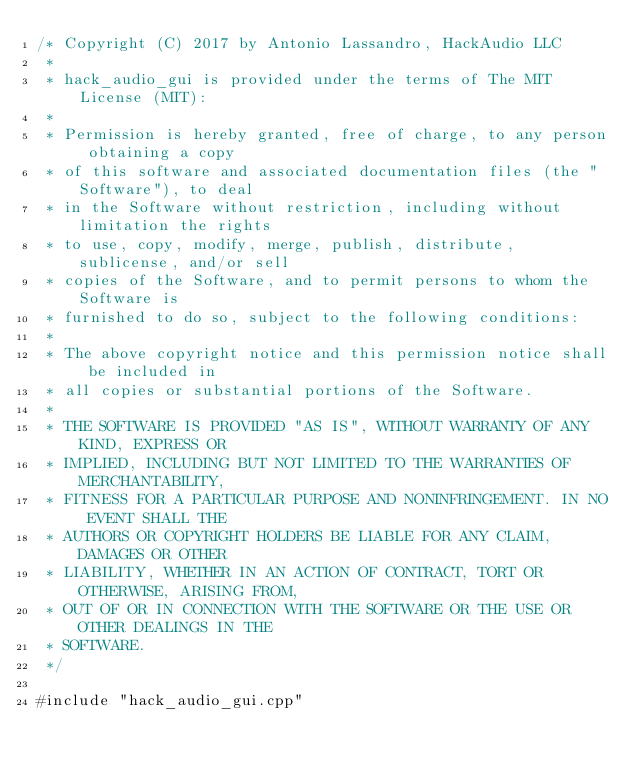<code> <loc_0><loc_0><loc_500><loc_500><_ObjectiveC_>/* Copyright (C) 2017 by Antonio Lassandro, HackAudio LLC
 *
 * hack_audio_gui is provided under the terms of The MIT License (MIT):
 *
 * Permission is hereby granted, free of charge, to any person obtaining a copy 
 * of this software and associated documentation files (the "Software"), to deal
 * in the Software without restriction, including without limitation the rights 
 * to use, copy, modify, merge, publish, distribute, sublicense, and/or sell 
 * copies of the Software, and to permit persons to whom the Software is 
 * furnished to do so, subject to the following conditions:
 *
 * The above copyright notice and this permission notice shall be included in 
 * all copies or substantial portions of the Software.
 *
 * THE SOFTWARE IS PROVIDED "AS IS", WITHOUT WARRANTY OF ANY KIND, EXPRESS OR 
 * IMPLIED, INCLUDING BUT NOT LIMITED TO THE WARRANTIES OF MERCHANTABILITY, 
 * FITNESS FOR A PARTICULAR PURPOSE AND NONINFRINGEMENT. IN NO EVENT SHALL THE 
 * AUTHORS OR COPYRIGHT HOLDERS BE LIABLE FOR ANY CLAIM, DAMAGES OR OTHER 
 * LIABILITY, WHETHER IN AN ACTION OF CONTRACT, TORT OR OTHERWISE, ARISING FROM,
 * OUT OF OR IN CONNECTION WITH THE SOFTWARE OR THE USE OR OTHER DEALINGS IN THE 
 * SOFTWARE.
 */

#include "hack_audio_gui.cpp"
</code> 